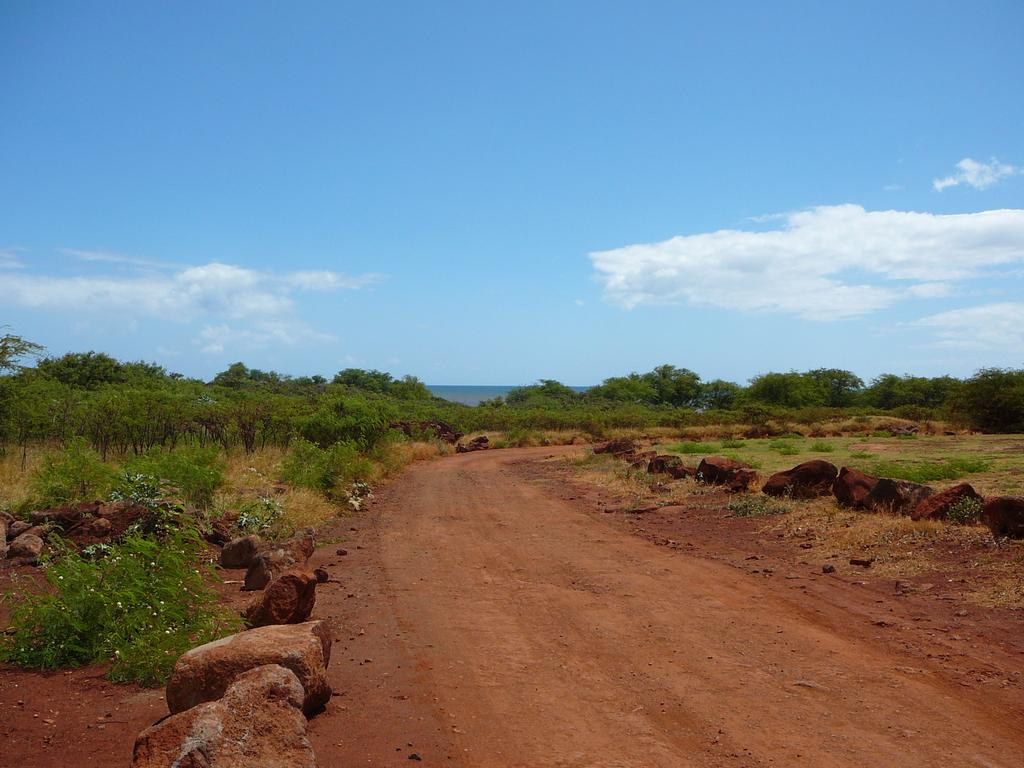What type of natural elements can be seen in the image? There are rocks, plants, and trees in the image. What can be seen in the background of the image? The sky is visible in the background of the image. How many layers of frosting are on the cake in the image? There is no cake present in the image; it features rocks, plants, trees, and the sky. 